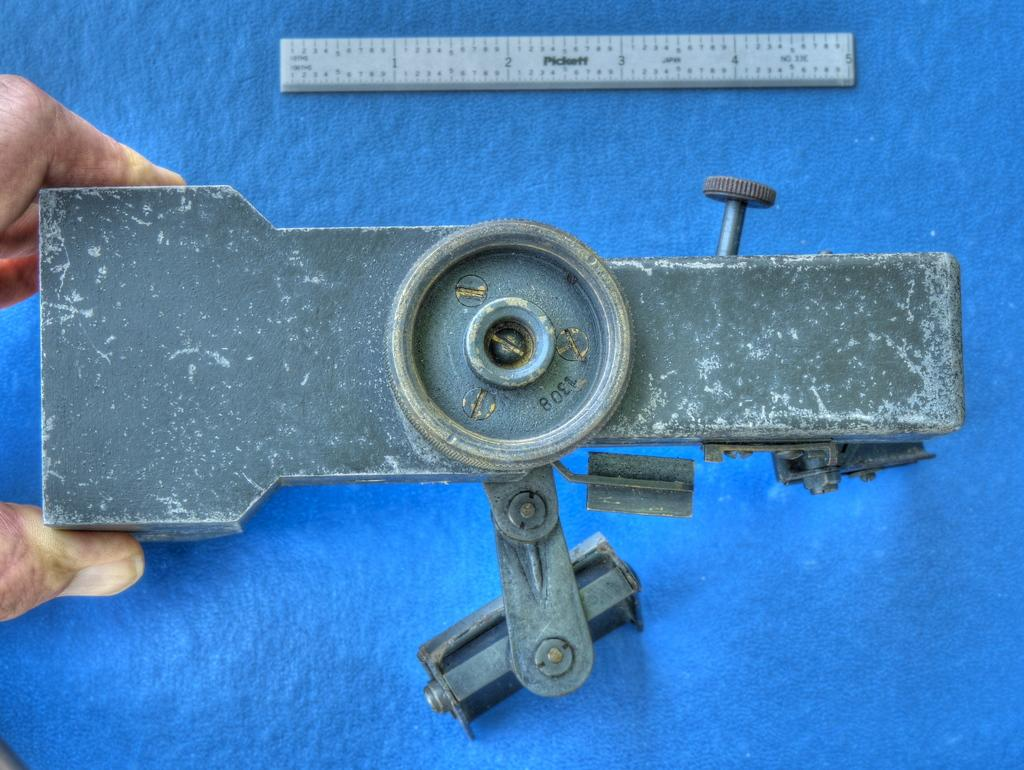<image>
Summarize the visual content of the image. A Pickett ruler is laid on a table next to a piece of equipment. 